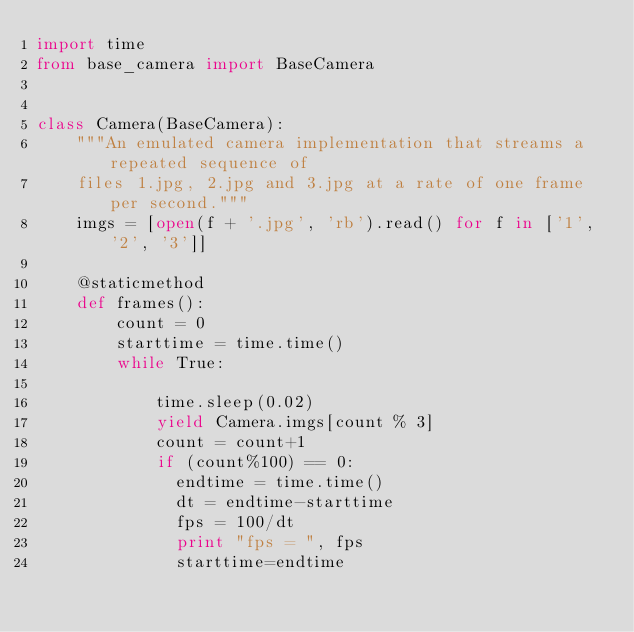<code> <loc_0><loc_0><loc_500><loc_500><_Python_>import time
from base_camera import BaseCamera


class Camera(BaseCamera):
    """An emulated camera implementation that streams a repeated sequence of
    files 1.jpg, 2.jpg and 3.jpg at a rate of one frame per second."""
    imgs = [open(f + '.jpg', 'rb').read() for f in ['1', '2', '3']]

    @staticmethod
    def frames():
        count = 0
        starttime = time.time()
        while True:

            time.sleep(0.02)
            yield Camera.imgs[count % 3]
            count = count+1
            if (count%100) == 0:
              endtime = time.time()
              dt = endtime-starttime
              fps = 100/dt
              print "fps = ", fps
              starttime=endtime
</code> 